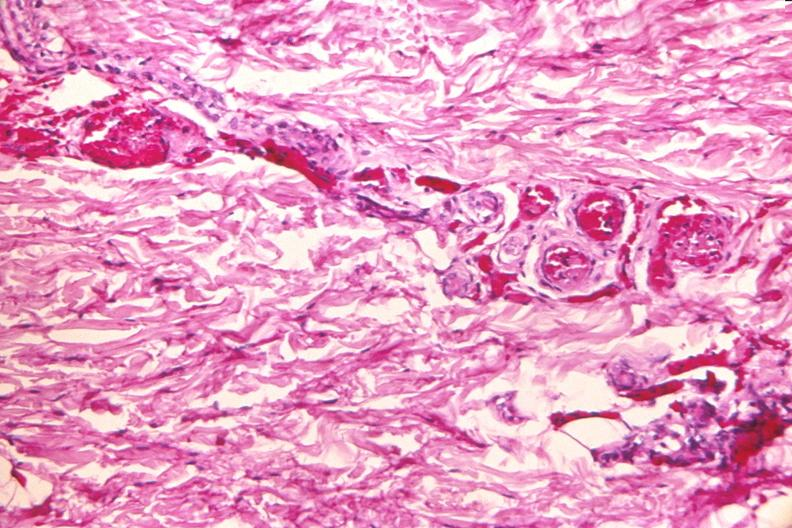what does this image show?
Answer the question using a single word or phrase. Skin 